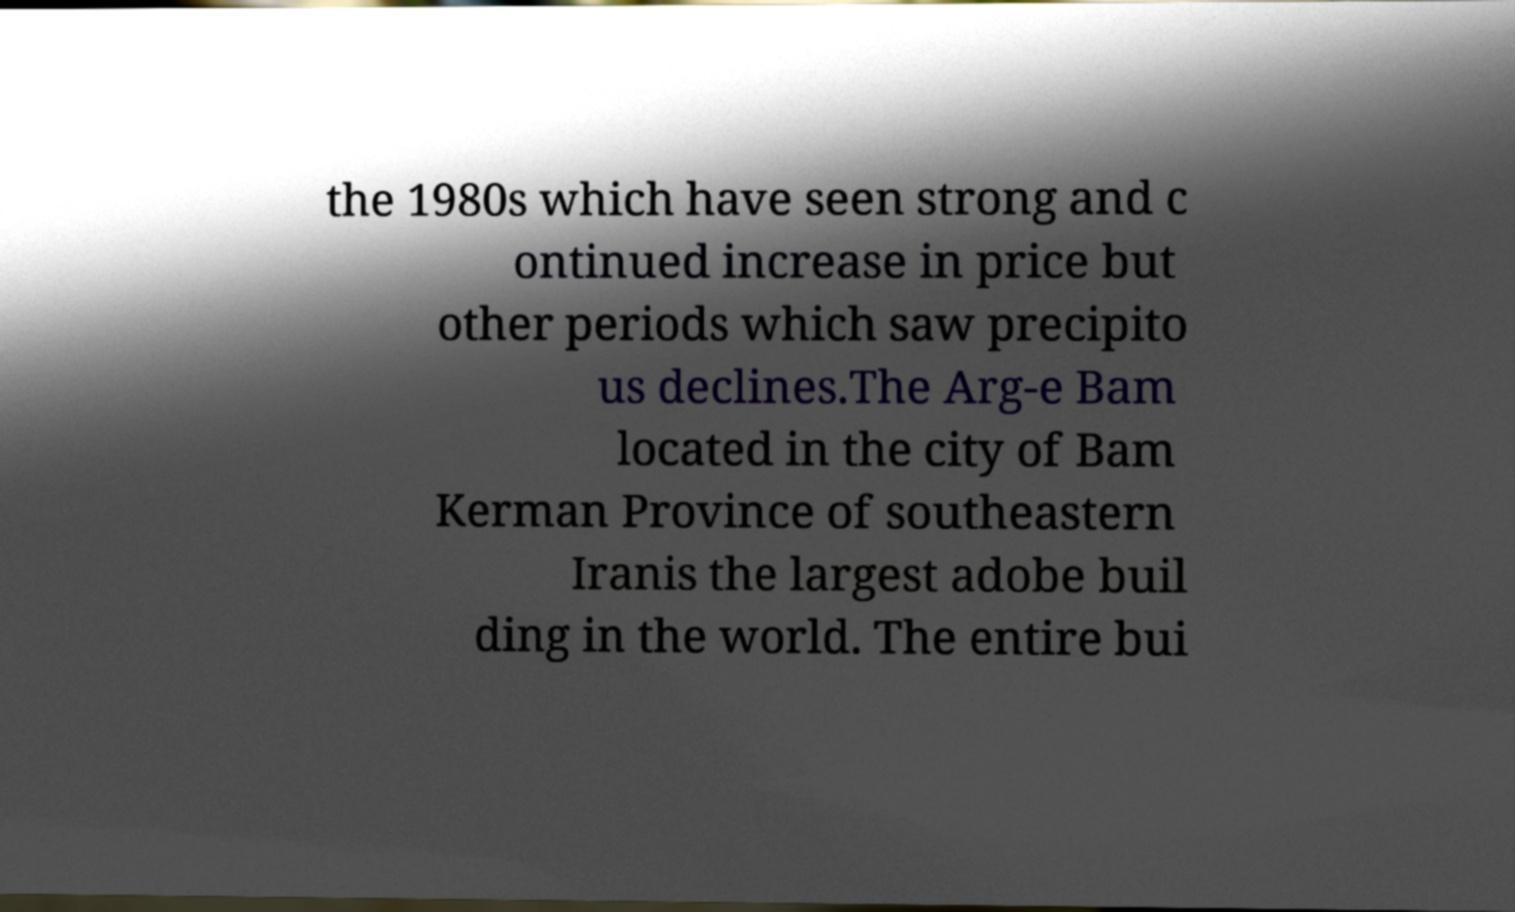For documentation purposes, I need the text within this image transcribed. Could you provide that? the 1980s which have seen strong and c ontinued increase in price but other periods which saw precipito us declines.The Arg-e Bam located in the city of Bam Kerman Province of southeastern Iranis the largest adobe buil ding in the world. The entire bui 